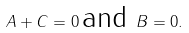Convert formula to latex. <formula><loc_0><loc_0><loc_500><loc_500>A + C = 0 \, \text {and\ } B = 0 .</formula> 